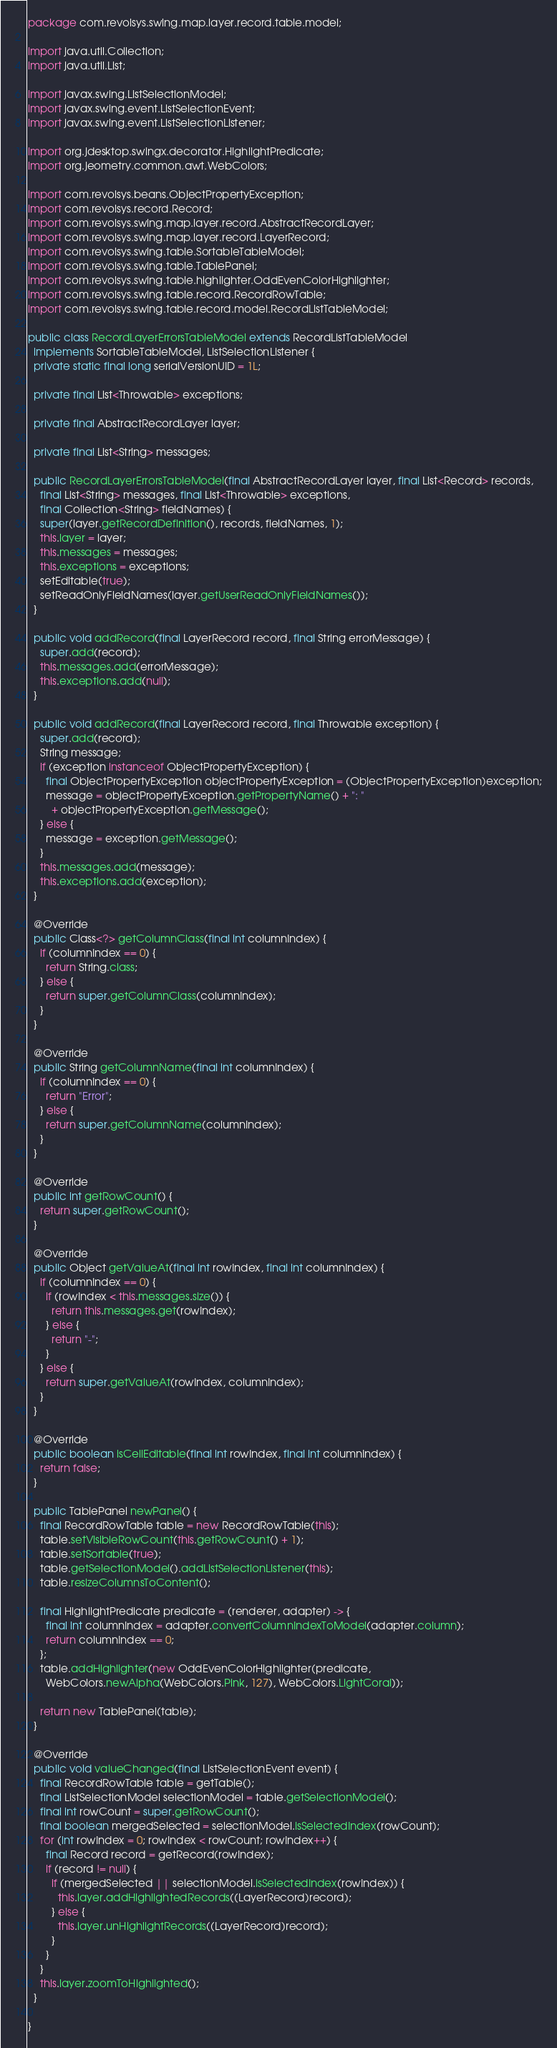Convert code to text. <code><loc_0><loc_0><loc_500><loc_500><_Java_>package com.revolsys.swing.map.layer.record.table.model;

import java.util.Collection;
import java.util.List;

import javax.swing.ListSelectionModel;
import javax.swing.event.ListSelectionEvent;
import javax.swing.event.ListSelectionListener;

import org.jdesktop.swingx.decorator.HighlightPredicate;
import org.jeometry.common.awt.WebColors;

import com.revolsys.beans.ObjectPropertyException;
import com.revolsys.record.Record;
import com.revolsys.swing.map.layer.record.AbstractRecordLayer;
import com.revolsys.swing.map.layer.record.LayerRecord;
import com.revolsys.swing.table.SortableTableModel;
import com.revolsys.swing.table.TablePanel;
import com.revolsys.swing.table.highlighter.OddEvenColorHighlighter;
import com.revolsys.swing.table.record.RecordRowTable;
import com.revolsys.swing.table.record.model.RecordListTableModel;

public class RecordLayerErrorsTableModel extends RecordListTableModel
  implements SortableTableModel, ListSelectionListener {
  private static final long serialVersionUID = 1L;

  private final List<Throwable> exceptions;

  private final AbstractRecordLayer layer;

  private final List<String> messages;

  public RecordLayerErrorsTableModel(final AbstractRecordLayer layer, final List<Record> records,
    final List<String> messages, final List<Throwable> exceptions,
    final Collection<String> fieldNames) {
    super(layer.getRecordDefinition(), records, fieldNames, 1);
    this.layer = layer;
    this.messages = messages;
    this.exceptions = exceptions;
    setEditable(true);
    setReadOnlyFieldNames(layer.getUserReadOnlyFieldNames());
  }

  public void addRecord(final LayerRecord record, final String errorMessage) {
    super.add(record);
    this.messages.add(errorMessage);
    this.exceptions.add(null);
  }

  public void addRecord(final LayerRecord record, final Throwable exception) {
    super.add(record);
    String message;
    if (exception instanceof ObjectPropertyException) {
      final ObjectPropertyException objectPropertyException = (ObjectPropertyException)exception;
      message = objectPropertyException.getPropertyName() + ": "
        + objectPropertyException.getMessage();
    } else {
      message = exception.getMessage();
    }
    this.messages.add(message);
    this.exceptions.add(exception);
  }

  @Override
  public Class<?> getColumnClass(final int columnIndex) {
    if (columnIndex == 0) {
      return String.class;
    } else {
      return super.getColumnClass(columnIndex);
    }
  }

  @Override
  public String getColumnName(final int columnIndex) {
    if (columnIndex == 0) {
      return "Error";
    } else {
      return super.getColumnName(columnIndex);
    }
  }

  @Override
  public int getRowCount() {
    return super.getRowCount();
  }

  @Override
  public Object getValueAt(final int rowIndex, final int columnIndex) {
    if (columnIndex == 0) {
      if (rowIndex < this.messages.size()) {
        return this.messages.get(rowIndex);
      } else {
        return "-";
      }
    } else {
      return super.getValueAt(rowIndex, columnIndex);
    }
  }

  @Override
  public boolean isCellEditable(final int rowIndex, final int columnIndex) {
    return false;
  }

  public TablePanel newPanel() {
    final RecordRowTable table = new RecordRowTable(this);
    table.setVisibleRowCount(this.getRowCount() + 1);
    table.setSortable(true);
    table.getSelectionModel().addListSelectionListener(this);
    table.resizeColumnsToContent();

    final HighlightPredicate predicate = (renderer, adapter) -> {
      final int columnIndex = adapter.convertColumnIndexToModel(adapter.column);
      return columnIndex == 0;
    };
    table.addHighlighter(new OddEvenColorHighlighter(predicate,
      WebColors.newAlpha(WebColors.Pink, 127), WebColors.LightCoral));

    return new TablePanel(table);
  }

  @Override
  public void valueChanged(final ListSelectionEvent event) {
    final RecordRowTable table = getTable();
    final ListSelectionModel selectionModel = table.getSelectionModel();
    final int rowCount = super.getRowCount();
    final boolean mergedSelected = selectionModel.isSelectedIndex(rowCount);
    for (int rowIndex = 0; rowIndex < rowCount; rowIndex++) {
      final Record record = getRecord(rowIndex);
      if (record != null) {
        if (mergedSelected || selectionModel.isSelectedIndex(rowIndex)) {
          this.layer.addHighlightedRecords((LayerRecord)record);
        } else {
          this.layer.unHighlightRecords((LayerRecord)record);
        }
      }
    }
    this.layer.zoomToHighlighted();
  }

}
</code> 